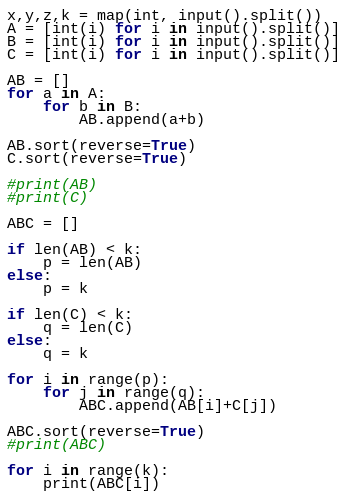<code> <loc_0><loc_0><loc_500><loc_500><_Python_>x,y,z,k = map(int, input().split())
A = [int(i) for i in input().split()]
B = [int(i) for i in input().split()]
C = [int(i) for i in input().split()]

AB = []
for a in A:
	for b in B:
		AB.append(a+b)

AB.sort(reverse=True)
C.sort(reverse=True)

#print(AB)
#print(C)

ABC = []

if len(AB) < k:
	p = len(AB)
else:
	p = k

if len(C) < k:
	q = len(C)
else:
	q = k

for i in range(p):
	for j in range(q):
		ABC.append(AB[i]+C[j])

ABC.sort(reverse=True)
#print(ABC)

for i in range(k):
	print(ABC[i])</code> 